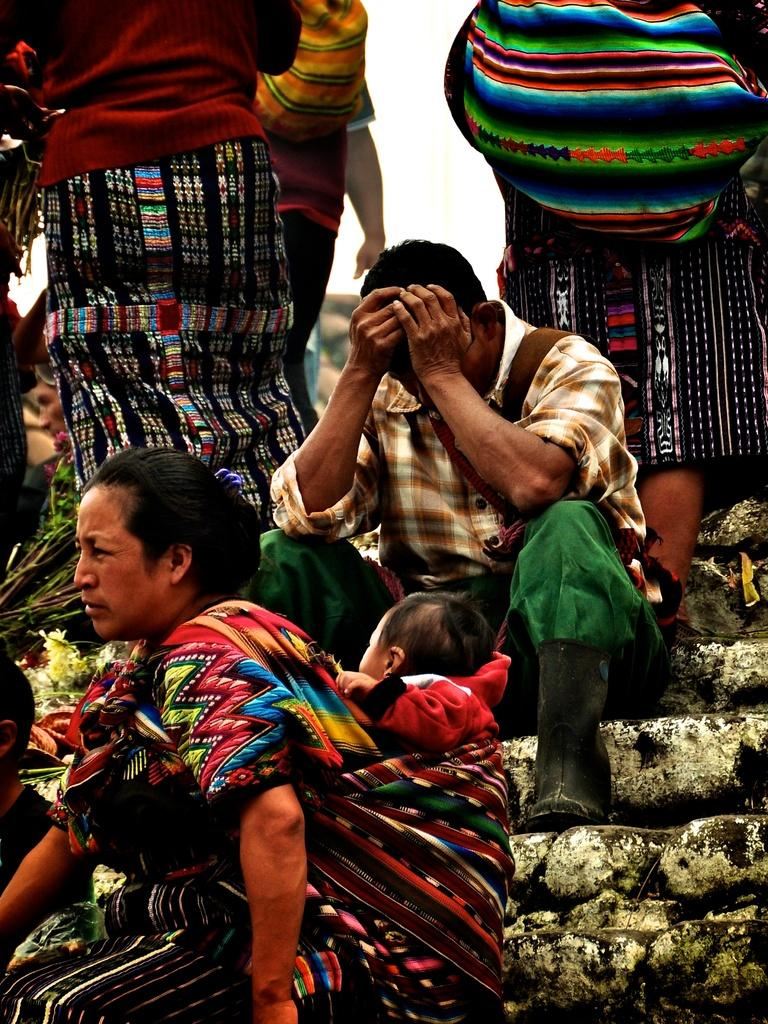What are the people in the image doing? There is a group of people sitting on the stairs. Can you describe the woman in the image? The woman is carrying a baby. How many people are standing in the image? There are three persons standing. What can be seen in the background of the image? The sky is visible in the background. Where is the nest located in the image? There is no nest present in the image. What type of material is the baby rubbing against in the image? The baby is being carried by the woman, so there is no rubbing against any material in the image. 